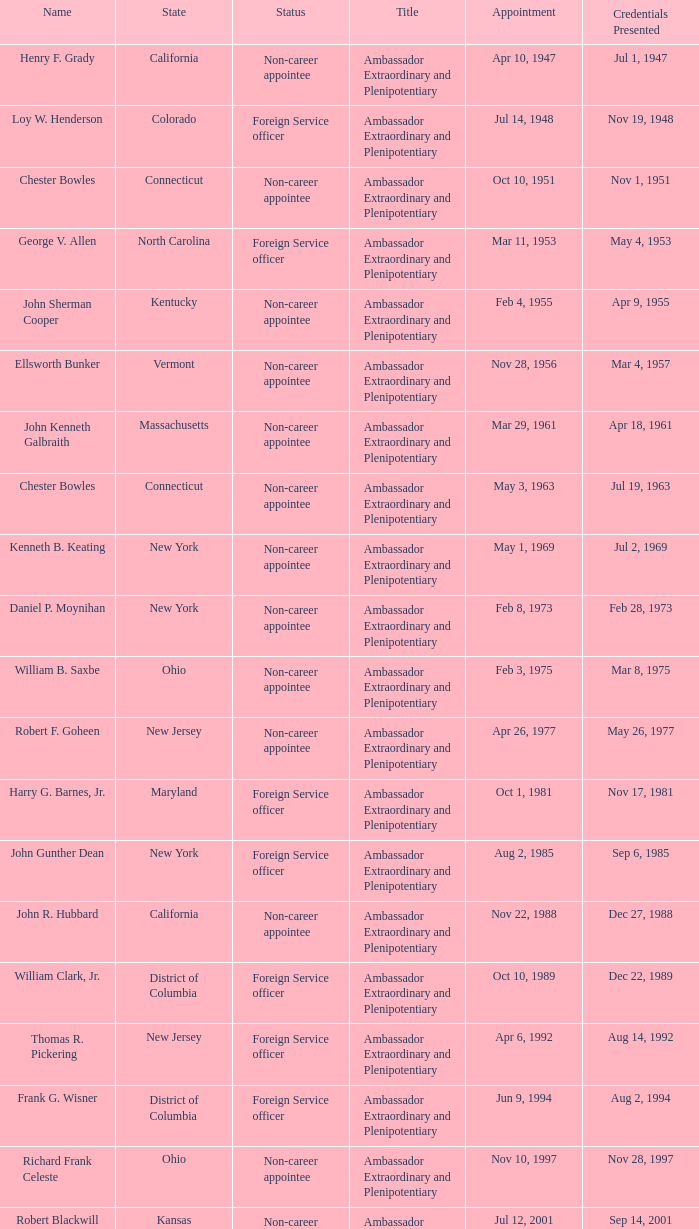What day were credentials presented for vermont? Mar 4, 1957. 